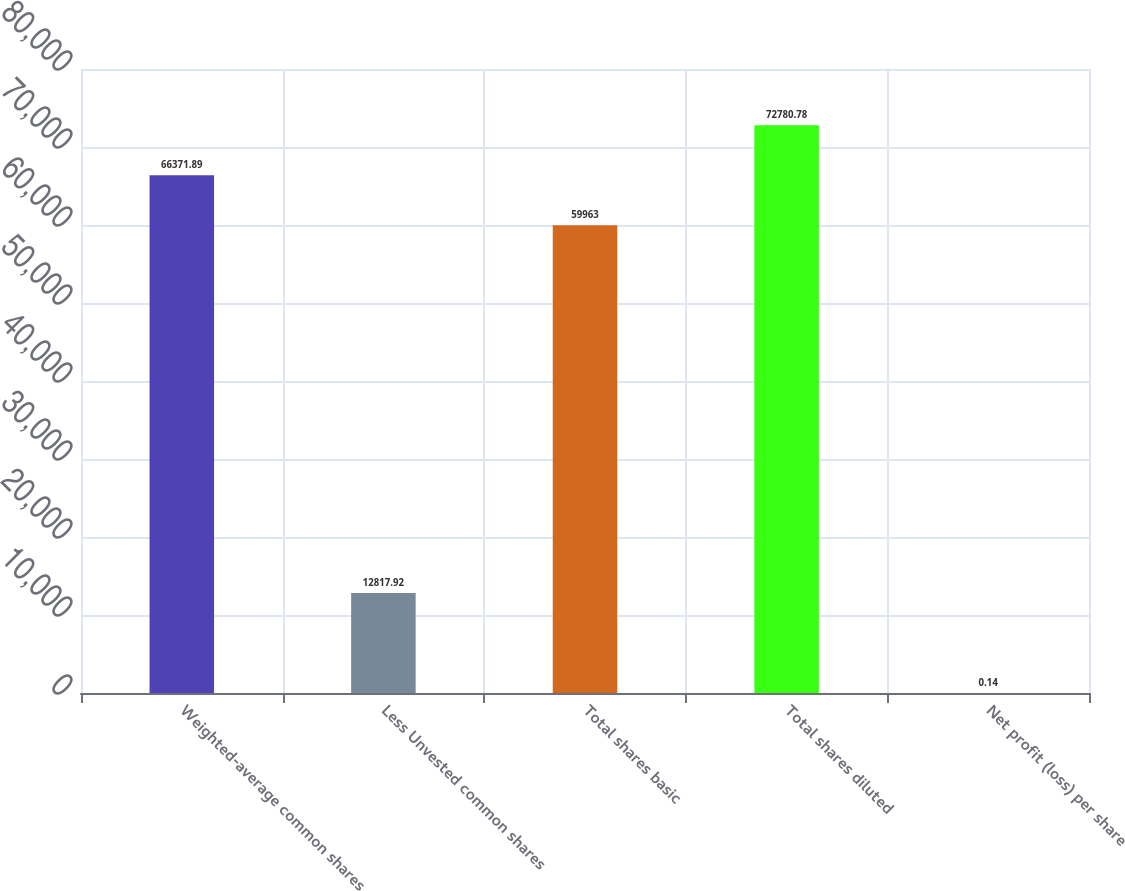Convert chart to OTSL. <chart><loc_0><loc_0><loc_500><loc_500><bar_chart><fcel>Weighted-average common shares<fcel>Less Unvested common shares<fcel>Total shares basic<fcel>Total shares diluted<fcel>Net profit (loss) per share<nl><fcel>66371.9<fcel>12817.9<fcel>59963<fcel>72780.8<fcel>0.14<nl></chart> 